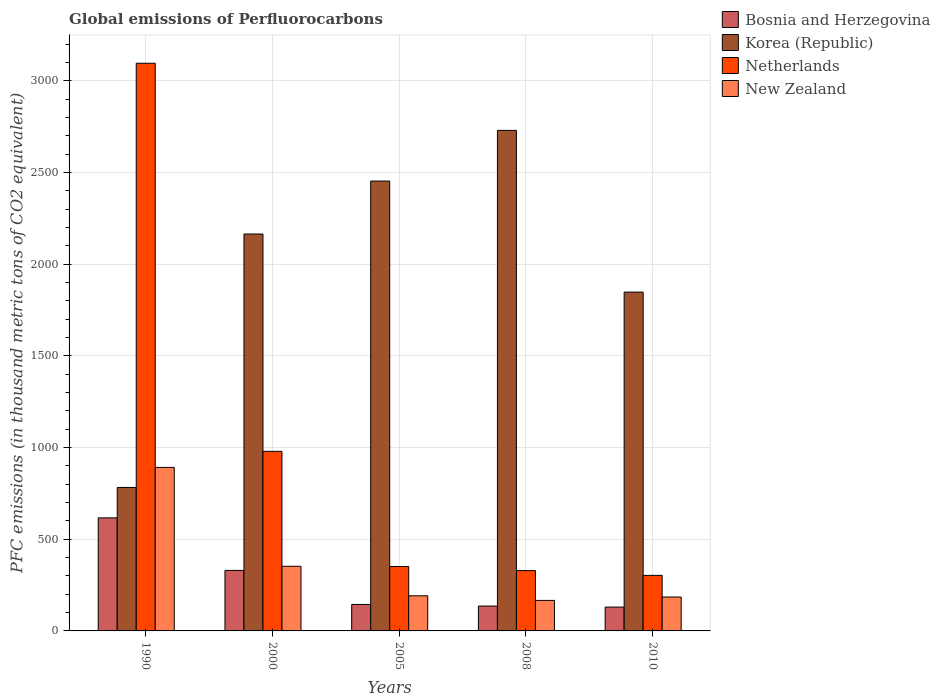How many different coloured bars are there?
Your answer should be very brief. 4. Are the number of bars per tick equal to the number of legend labels?
Provide a succinct answer. Yes. How many bars are there on the 5th tick from the left?
Offer a very short reply. 4. In how many cases, is the number of bars for a given year not equal to the number of legend labels?
Give a very brief answer. 0. What is the global emissions of Perfluorocarbons in Bosnia and Herzegovina in 1990?
Keep it short and to the point. 616.7. Across all years, what is the maximum global emissions of Perfluorocarbons in Korea (Republic)?
Provide a succinct answer. 2730.1. Across all years, what is the minimum global emissions of Perfluorocarbons in Bosnia and Herzegovina?
Provide a short and direct response. 130. What is the total global emissions of Perfluorocarbons in New Zealand in the graph?
Your answer should be very brief. 1787.4. What is the difference between the global emissions of Perfluorocarbons in Korea (Republic) in 1990 and that in 2010?
Your answer should be compact. -1065.4. What is the difference between the global emissions of Perfluorocarbons in Korea (Republic) in 2000 and the global emissions of Perfluorocarbons in Netherlands in 2005?
Your answer should be very brief. 1813.5. What is the average global emissions of Perfluorocarbons in Korea (Republic) per year?
Your answer should be very brief. 1995.86. In the year 2010, what is the difference between the global emissions of Perfluorocarbons in Netherlands and global emissions of Perfluorocarbons in Korea (Republic)?
Offer a very short reply. -1545. In how many years, is the global emissions of Perfluorocarbons in New Zealand greater than 2700 thousand metric tons?
Ensure brevity in your answer.  0. What is the ratio of the global emissions of Perfluorocarbons in Korea (Republic) in 2005 to that in 2008?
Offer a very short reply. 0.9. What is the difference between the highest and the second highest global emissions of Perfluorocarbons in New Zealand?
Your response must be concise. 539.2. What is the difference between the highest and the lowest global emissions of Perfluorocarbons in New Zealand?
Your answer should be compact. 725.4. In how many years, is the global emissions of Perfluorocarbons in Bosnia and Herzegovina greater than the average global emissions of Perfluorocarbons in Bosnia and Herzegovina taken over all years?
Your answer should be compact. 2. Is the sum of the global emissions of Perfluorocarbons in Korea (Republic) in 1990 and 2010 greater than the maximum global emissions of Perfluorocarbons in Netherlands across all years?
Your response must be concise. No. Is it the case that in every year, the sum of the global emissions of Perfluorocarbons in Bosnia and Herzegovina and global emissions of Perfluorocarbons in Korea (Republic) is greater than the sum of global emissions of Perfluorocarbons in New Zealand and global emissions of Perfluorocarbons in Netherlands?
Make the answer very short. No. What does the 4th bar from the left in 2010 represents?
Your answer should be very brief. New Zealand. What does the 4th bar from the right in 2005 represents?
Your response must be concise. Bosnia and Herzegovina. How many bars are there?
Your response must be concise. 20. Are all the bars in the graph horizontal?
Keep it short and to the point. No. How many years are there in the graph?
Your answer should be compact. 5. Does the graph contain any zero values?
Your answer should be compact. No. How many legend labels are there?
Offer a very short reply. 4. What is the title of the graph?
Your answer should be compact. Global emissions of Perfluorocarbons. Does "Liechtenstein" appear as one of the legend labels in the graph?
Keep it short and to the point. No. What is the label or title of the Y-axis?
Make the answer very short. PFC emissions (in thousand metric tons of CO2 equivalent). What is the PFC emissions (in thousand metric tons of CO2 equivalent) of Bosnia and Herzegovina in 1990?
Your answer should be compact. 616.7. What is the PFC emissions (in thousand metric tons of CO2 equivalent) in Korea (Republic) in 1990?
Give a very brief answer. 782.6. What is the PFC emissions (in thousand metric tons of CO2 equivalent) of Netherlands in 1990?
Your answer should be very brief. 3096.2. What is the PFC emissions (in thousand metric tons of CO2 equivalent) in New Zealand in 1990?
Your response must be concise. 891.8. What is the PFC emissions (in thousand metric tons of CO2 equivalent) of Bosnia and Herzegovina in 2000?
Your response must be concise. 329.9. What is the PFC emissions (in thousand metric tons of CO2 equivalent) in Korea (Republic) in 2000?
Keep it short and to the point. 2164.9. What is the PFC emissions (in thousand metric tons of CO2 equivalent) of Netherlands in 2000?
Offer a terse response. 979.5. What is the PFC emissions (in thousand metric tons of CO2 equivalent) in New Zealand in 2000?
Make the answer very short. 352.6. What is the PFC emissions (in thousand metric tons of CO2 equivalent) in Bosnia and Herzegovina in 2005?
Give a very brief answer. 144.4. What is the PFC emissions (in thousand metric tons of CO2 equivalent) in Korea (Republic) in 2005?
Your answer should be very brief. 2453.7. What is the PFC emissions (in thousand metric tons of CO2 equivalent) in Netherlands in 2005?
Provide a succinct answer. 351.4. What is the PFC emissions (in thousand metric tons of CO2 equivalent) in New Zealand in 2005?
Keep it short and to the point. 191.6. What is the PFC emissions (in thousand metric tons of CO2 equivalent) in Bosnia and Herzegovina in 2008?
Give a very brief answer. 135.6. What is the PFC emissions (in thousand metric tons of CO2 equivalent) of Korea (Republic) in 2008?
Your answer should be very brief. 2730.1. What is the PFC emissions (in thousand metric tons of CO2 equivalent) in Netherlands in 2008?
Provide a succinct answer. 329.2. What is the PFC emissions (in thousand metric tons of CO2 equivalent) in New Zealand in 2008?
Offer a terse response. 166.4. What is the PFC emissions (in thousand metric tons of CO2 equivalent) in Bosnia and Herzegovina in 2010?
Make the answer very short. 130. What is the PFC emissions (in thousand metric tons of CO2 equivalent) in Korea (Republic) in 2010?
Provide a succinct answer. 1848. What is the PFC emissions (in thousand metric tons of CO2 equivalent) of Netherlands in 2010?
Provide a succinct answer. 303. What is the PFC emissions (in thousand metric tons of CO2 equivalent) in New Zealand in 2010?
Offer a terse response. 185. Across all years, what is the maximum PFC emissions (in thousand metric tons of CO2 equivalent) in Bosnia and Herzegovina?
Make the answer very short. 616.7. Across all years, what is the maximum PFC emissions (in thousand metric tons of CO2 equivalent) in Korea (Republic)?
Your response must be concise. 2730.1. Across all years, what is the maximum PFC emissions (in thousand metric tons of CO2 equivalent) in Netherlands?
Your answer should be very brief. 3096.2. Across all years, what is the maximum PFC emissions (in thousand metric tons of CO2 equivalent) of New Zealand?
Give a very brief answer. 891.8. Across all years, what is the minimum PFC emissions (in thousand metric tons of CO2 equivalent) in Bosnia and Herzegovina?
Provide a succinct answer. 130. Across all years, what is the minimum PFC emissions (in thousand metric tons of CO2 equivalent) of Korea (Republic)?
Your answer should be compact. 782.6. Across all years, what is the minimum PFC emissions (in thousand metric tons of CO2 equivalent) of Netherlands?
Your response must be concise. 303. Across all years, what is the minimum PFC emissions (in thousand metric tons of CO2 equivalent) in New Zealand?
Offer a very short reply. 166.4. What is the total PFC emissions (in thousand metric tons of CO2 equivalent) of Bosnia and Herzegovina in the graph?
Your answer should be very brief. 1356.6. What is the total PFC emissions (in thousand metric tons of CO2 equivalent) of Korea (Republic) in the graph?
Make the answer very short. 9979.3. What is the total PFC emissions (in thousand metric tons of CO2 equivalent) of Netherlands in the graph?
Your answer should be compact. 5059.3. What is the total PFC emissions (in thousand metric tons of CO2 equivalent) of New Zealand in the graph?
Your answer should be compact. 1787.4. What is the difference between the PFC emissions (in thousand metric tons of CO2 equivalent) of Bosnia and Herzegovina in 1990 and that in 2000?
Provide a short and direct response. 286.8. What is the difference between the PFC emissions (in thousand metric tons of CO2 equivalent) of Korea (Republic) in 1990 and that in 2000?
Provide a short and direct response. -1382.3. What is the difference between the PFC emissions (in thousand metric tons of CO2 equivalent) in Netherlands in 1990 and that in 2000?
Offer a terse response. 2116.7. What is the difference between the PFC emissions (in thousand metric tons of CO2 equivalent) of New Zealand in 1990 and that in 2000?
Keep it short and to the point. 539.2. What is the difference between the PFC emissions (in thousand metric tons of CO2 equivalent) in Bosnia and Herzegovina in 1990 and that in 2005?
Give a very brief answer. 472.3. What is the difference between the PFC emissions (in thousand metric tons of CO2 equivalent) of Korea (Republic) in 1990 and that in 2005?
Provide a succinct answer. -1671.1. What is the difference between the PFC emissions (in thousand metric tons of CO2 equivalent) of Netherlands in 1990 and that in 2005?
Your answer should be very brief. 2744.8. What is the difference between the PFC emissions (in thousand metric tons of CO2 equivalent) of New Zealand in 1990 and that in 2005?
Provide a short and direct response. 700.2. What is the difference between the PFC emissions (in thousand metric tons of CO2 equivalent) in Bosnia and Herzegovina in 1990 and that in 2008?
Give a very brief answer. 481.1. What is the difference between the PFC emissions (in thousand metric tons of CO2 equivalent) of Korea (Republic) in 1990 and that in 2008?
Offer a very short reply. -1947.5. What is the difference between the PFC emissions (in thousand metric tons of CO2 equivalent) of Netherlands in 1990 and that in 2008?
Offer a very short reply. 2767. What is the difference between the PFC emissions (in thousand metric tons of CO2 equivalent) in New Zealand in 1990 and that in 2008?
Give a very brief answer. 725.4. What is the difference between the PFC emissions (in thousand metric tons of CO2 equivalent) in Bosnia and Herzegovina in 1990 and that in 2010?
Make the answer very short. 486.7. What is the difference between the PFC emissions (in thousand metric tons of CO2 equivalent) in Korea (Republic) in 1990 and that in 2010?
Provide a succinct answer. -1065.4. What is the difference between the PFC emissions (in thousand metric tons of CO2 equivalent) of Netherlands in 1990 and that in 2010?
Provide a succinct answer. 2793.2. What is the difference between the PFC emissions (in thousand metric tons of CO2 equivalent) in New Zealand in 1990 and that in 2010?
Keep it short and to the point. 706.8. What is the difference between the PFC emissions (in thousand metric tons of CO2 equivalent) in Bosnia and Herzegovina in 2000 and that in 2005?
Make the answer very short. 185.5. What is the difference between the PFC emissions (in thousand metric tons of CO2 equivalent) in Korea (Republic) in 2000 and that in 2005?
Provide a succinct answer. -288.8. What is the difference between the PFC emissions (in thousand metric tons of CO2 equivalent) of Netherlands in 2000 and that in 2005?
Make the answer very short. 628.1. What is the difference between the PFC emissions (in thousand metric tons of CO2 equivalent) of New Zealand in 2000 and that in 2005?
Your answer should be compact. 161. What is the difference between the PFC emissions (in thousand metric tons of CO2 equivalent) in Bosnia and Herzegovina in 2000 and that in 2008?
Ensure brevity in your answer.  194.3. What is the difference between the PFC emissions (in thousand metric tons of CO2 equivalent) in Korea (Republic) in 2000 and that in 2008?
Provide a succinct answer. -565.2. What is the difference between the PFC emissions (in thousand metric tons of CO2 equivalent) of Netherlands in 2000 and that in 2008?
Keep it short and to the point. 650.3. What is the difference between the PFC emissions (in thousand metric tons of CO2 equivalent) in New Zealand in 2000 and that in 2008?
Your answer should be very brief. 186.2. What is the difference between the PFC emissions (in thousand metric tons of CO2 equivalent) in Bosnia and Herzegovina in 2000 and that in 2010?
Your answer should be compact. 199.9. What is the difference between the PFC emissions (in thousand metric tons of CO2 equivalent) in Korea (Republic) in 2000 and that in 2010?
Keep it short and to the point. 316.9. What is the difference between the PFC emissions (in thousand metric tons of CO2 equivalent) of Netherlands in 2000 and that in 2010?
Provide a short and direct response. 676.5. What is the difference between the PFC emissions (in thousand metric tons of CO2 equivalent) in New Zealand in 2000 and that in 2010?
Provide a short and direct response. 167.6. What is the difference between the PFC emissions (in thousand metric tons of CO2 equivalent) of Bosnia and Herzegovina in 2005 and that in 2008?
Offer a very short reply. 8.8. What is the difference between the PFC emissions (in thousand metric tons of CO2 equivalent) of Korea (Republic) in 2005 and that in 2008?
Provide a succinct answer. -276.4. What is the difference between the PFC emissions (in thousand metric tons of CO2 equivalent) of New Zealand in 2005 and that in 2008?
Offer a terse response. 25.2. What is the difference between the PFC emissions (in thousand metric tons of CO2 equivalent) of Bosnia and Herzegovina in 2005 and that in 2010?
Offer a terse response. 14.4. What is the difference between the PFC emissions (in thousand metric tons of CO2 equivalent) in Korea (Republic) in 2005 and that in 2010?
Your answer should be compact. 605.7. What is the difference between the PFC emissions (in thousand metric tons of CO2 equivalent) of Netherlands in 2005 and that in 2010?
Keep it short and to the point. 48.4. What is the difference between the PFC emissions (in thousand metric tons of CO2 equivalent) of New Zealand in 2005 and that in 2010?
Your response must be concise. 6.6. What is the difference between the PFC emissions (in thousand metric tons of CO2 equivalent) in Korea (Republic) in 2008 and that in 2010?
Provide a succinct answer. 882.1. What is the difference between the PFC emissions (in thousand metric tons of CO2 equivalent) in Netherlands in 2008 and that in 2010?
Your response must be concise. 26.2. What is the difference between the PFC emissions (in thousand metric tons of CO2 equivalent) of New Zealand in 2008 and that in 2010?
Your answer should be very brief. -18.6. What is the difference between the PFC emissions (in thousand metric tons of CO2 equivalent) in Bosnia and Herzegovina in 1990 and the PFC emissions (in thousand metric tons of CO2 equivalent) in Korea (Republic) in 2000?
Give a very brief answer. -1548.2. What is the difference between the PFC emissions (in thousand metric tons of CO2 equivalent) of Bosnia and Herzegovina in 1990 and the PFC emissions (in thousand metric tons of CO2 equivalent) of Netherlands in 2000?
Make the answer very short. -362.8. What is the difference between the PFC emissions (in thousand metric tons of CO2 equivalent) in Bosnia and Herzegovina in 1990 and the PFC emissions (in thousand metric tons of CO2 equivalent) in New Zealand in 2000?
Your answer should be very brief. 264.1. What is the difference between the PFC emissions (in thousand metric tons of CO2 equivalent) of Korea (Republic) in 1990 and the PFC emissions (in thousand metric tons of CO2 equivalent) of Netherlands in 2000?
Keep it short and to the point. -196.9. What is the difference between the PFC emissions (in thousand metric tons of CO2 equivalent) of Korea (Republic) in 1990 and the PFC emissions (in thousand metric tons of CO2 equivalent) of New Zealand in 2000?
Your answer should be compact. 430. What is the difference between the PFC emissions (in thousand metric tons of CO2 equivalent) of Netherlands in 1990 and the PFC emissions (in thousand metric tons of CO2 equivalent) of New Zealand in 2000?
Your answer should be compact. 2743.6. What is the difference between the PFC emissions (in thousand metric tons of CO2 equivalent) of Bosnia and Herzegovina in 1990 and the PFC emissions (in thousand metric tons of CO2 equivalent) of Korea (Republic) in 2005?
Offer a very short reply. -1837. What is the difference between the PFC emissions (in thousand metric tons of CO2 equivalent) in Bosnia and Herzegovina in 1990 and the PFC emissions (in thousand metric tons of CO2 equivalent) in Netherlands in 2005?
Offer a terse response. 265.3. What is the difference between the PFC emissions (in thousand metric tons of CO2 equivalent) in Bosnia and Herzegovina in 1990 and the PFC emissions (in thousand metric tons of CO2 equivalent) in New Zealand in 2005?
Provide a short and direct response. 425.1. What is the difference between the PFC emissions (in thousand metric tons of CO2 equivalent) in Korea (Republic) in 1990 and the PFC emissions (in thousand metric tons of CO2 equivalent) in Netherlands in 2005?
Provide a succinct answer. 431.2. What is the difference between the PFC emissions (in thousand metric tons of CO2 equivalent) in Korea (Republic) in 1990 and the PFC emissions (in thousand metric tons of CO2 equivalent) in New Zealand in 2005?
Offer a very short reply. 591. What is the difference between the PFC emissions (in thousand metric tons of CO2 equivalent) of Netherlands in 1990 and the PFC emissions (in thousand metric tons of CO2 equivalent) of New Zealand in 2005?
Your response must be concise. 2904.6. What is the difference between the PFC emissions (in thousand metric tons of CO2 equivalent) in Bosnia and Herzegovina in 1990 and the PFC emissions (in thousand metric tons of CO2 equivalent) in Korea (Republic) in 2008?
Ensure brevity in your answer.  -2113.4. What is the difference between the PFC emissions (in thousand metric tons of CO2 equivalent) of Bosnia and Herzegovina in 1990 and the PFC emissions (in thousand metric tons of CO2 equivalent) of Netherlands in 2008?
Your answer should be very brief. 287.5. What is the difference between the PFC emissions (in thousand metric tons of CO2 equivalent) of Bosnia and Herzegovina in 1990 and the PFC emissions (in thousand metric tons of CO2 equivalent) of New Zealand in 2008?
Offer a very short reply. 450.3. What is the difference between the PFC emissions (in thousand metric tons of CO2 equivalent) in Korea (Republic) in 1990 and the PFC emissions (in thousand metric tons of CO2 equivalent) in Netherlands in 2008?
Provide a succinct answer. 453.4. What is the difference between the PFC emissions (in thousand metric tons of CO2 equivalent) in Korea (Republic) in 1990 and the PFC emissions (in thousand metric tons of CO2 equivalent) in New Zealand in 2008?
Your answer should be very brief. 616.2. What is the difference between the PFC emissions (in thousand metric tons of CO2 equivalent) of Netherlands in 1990 and the PFC emissions (in thousand metric tons of CO2 equivalent) of New Zealand in 2008?
Make the answer very short. 2929.8. What is the difference between the PFC emissions (in thousand metric tons of CO2 equivalent) in Bosnia and Herzegovina in 1990 and the PFC emissions (in thousand metric tons of CO2 equivalent) in Korea (Republic) in 2010?
Your answer should be very brief. -1231.3. What is the difference between the PFC emissions (in thousand metric tons of CO2 equivalent) of Bosnia and Herzegovina in 1990 and the PFC emissions (in thousand metric tons of CO2 equivalent) of Netherlands in 2010?
Make the answer very short. 313.7. What is the difference between the PFC emissions (in thousand metric tons of CO2 equivalent) in Bosnia and Herzegovina in 1990 and the PFC emissions (in thousand metric tons of CO2 equivalent) in New Zealand in 2010?
Make the answer very short. 431.7. What is the difference between the PFC emissions (in thousand metric tons of CO2 equivalent) of Korea (Republic) in 1990 and the PFC emissions (in thousand metric tons of CO2 equivalent) of Netherlands in 2010?
Provide a succinct answer. 479.6. What is the difference between the PFC emissions (in thousand metric tons of CO2 equivalent) of Korea (Republic) in 1990 and the PFC emissions (in thousand metric tons of CO2 equivalent) of New Zealand in 2010?
Provide a succinct answer. 597.6. What is the difference between the PFC emissions (in thousand metric tons of CO2 equivalent) in Netherlands in 1990 and the PFC emissions (in thousand metric tons of CO2 equivalent) in New Zealand in 2010?
Offer a very short reply. 2911.2. What is the difference between the PFC emissions (in thousand metric tons of CO2 equivalent) of Bosnia and Herzegovina in 2000 and the PFC emissions (in thousand metric tons of CO2 equivalent) of Korea (Republic) in 2005?
Keep it short and to the point. -2123.8. What is the difference between the PFC emissions (in thousand metric tons of CO2 equivalent) of Bosnia and Herzegovina in 2000 and the PFC emissions (in thousand metric tons of CO2 equivalent) of Netherlands in 2005?
Your answer should be very brief. -21.5. What is the difference between the PFC emissions (in thousand metric tons of CO2 equivalent) in Bosnia and Herzegovina in 2000 and the PFC emissions (in thousand metric tons of CO2 equivalent) in New Zealand in 2005?
Offer a terse response. 138.3. What is the difference between the PFC emissions (in thousand metric tons of CO2 equivalent) in Korea (Republic) in 2000 and the PFC emissions (in thousand metric tons of CO2 equivalent) in Netherlands in 2005?
Offer a terse response. 1813.5. What is the difference between the PFC emissions (in thousand metric tons of CO2 equivalent) in Korea (Republic) in 2000 and the PFC emissions (in thousand metric tons of CO2 equivalent) in New Zealand in 2005?
Keep it short and to the point. 1973.3. What is the difference between the PFC emissions (in thousand metric tons of CO2 equivalent) in Netherlands in 2000 and the PFC emissions (in thousand metric tons of CO2 equivalent) in New Zealand in 2005?
Offer a terse response. 787.9. What is the difference between the PFC emissions (in thousand metric tons of CO2 equivalent) in Bosnia and Herzegovina in 2000 and the PFC emissions (in thousand metric tons of CO2 equivalent) in Korea (Republic) in 2008?
Make the answer very short. -2400.2. What is the difference between the PFC emissions (in thousand metric tons of CO2 equivalent) in Bosnia and Herzegovina in 2000 and the PFC emissions (in thousand metric tons of CO2 equivalent) in Netherlands in 2008?
Provide a short and direct response. 0.7. What is the difference between the PFC emissions (in thousand metric tons of CO2 equivalent) of Bosnia and Herzegovina in 2000 and the PFC emissions (in thousand metric tons of CO2 equivalent) of New Zealand in 2008?
Give a very brief answer. 163.5. What is the difference between the PFC emissions (in thousand metric tons of CO2 equivalent) in Korea (Republic) in 2000 and the PFC emissions (in thousand metric tons of CO2 equivalent) in Netherlands in 2008?
Keep it short and to the point. 1835.7. What is the difference between the PFC emissions (in thousand metric tons of CO2 equivalent) of Korea (Republic) in 2000 and the PFC emissions (in thousand metric tons of CO2 equivalent) of New Zealand in 2008?
Provide a succinct answer. 1998.5. What is the difference between the PFC emissions (in thousand metric tons of CO2 equivalent) of Netherlands in 2000 and the PFC emissions (in thousand metric tons of CO2 equivalent) of New Zealand in 2008?
Make the answer very short. 813.1. What is the difference between the PFC emissions (in thousand metric tons of CO2 equivalent) in Bosnia and Herzegovina in 2000 and the PFC emissions (in thousand metric tons of CO2 equivalent) in Korea (Republic) in 2010?
Make the answer very short. -1518.1. What is the difference between the PFC emissions (in thousand metric tons of CO2 equivalent) of Bosnia and Herzegovina in 2000 and the PFC emissions (in thousand metric tons of CO2 equivalent) of Netherlands in 2010?
Offer a terse response. 26.9. What is the difference between the PFC emissions (in thousand metric tons of CO2 equivalent) in Bosnia and Herzegovina in 2000 and the PFC emissions (in thousand metric tons of CO2 equivalent) in New Zealand in 2010?
Ensure brevity in your answer.  144.9. What is the difference between the PFC emissions (in thousand metric tons of CO2 equivalent) of Korea (Republic) in 2000 and the PFC emissions (in thousand metric tons of CO2 equivalent) of Netherlands in 2010?
Your answer should be very brief. 1861.9. What is the difference between the PFC emissions (in thousand metric tons of CO2 equivalent) in Korea (Republic) in 2000 and the PFC emissions (in thousand metric tons of CO2 equivalent) in New Zealand in 2010?
Provide a succinct answer. 1979.9. What is the difference between the PFC emissions (in thousand metric tons of CO2 equivalent) of Netherlands in 2000 and the PFC emissions (in thousand metric tons of CO2 equivalent) of New Zealand in 2010?
Ensure brevity in your answer.  794.5. What is the difference between the PFC emissions (in thousand metric tons of CO2 equivalent) in Bosnia and Herzegovina in 2005 and the PFC emissions (in thousand metric tons of CO2 equivalent) in Korea (Republic) in 2008?
Make the answer very short. -2585.7. What is the difference between the PFC emissions (in thousand metric tons of CO2 equivalent) in Bosnia and Herzegovina in 2005 and the PFC emissions (in thousand metric tons of CO2 equivalent) in Netherlands in 2008?
Ensure brevity in your answer.  -184.8. What is the difference between the PFC emissions (in thousand metric tons of CO2 equivalent) in Korea (Republic) in 2005 and the PFC emissions (in thousand metric tons of CO2 equivalent) in Netherlands in 2008?
Provide a succinct answer. 2124.5. What is the difference between the PFC emissions (in thousand metric tons of CO2 equivalent) of Korea (Republic) in 2005 and the PFC emissions (in thousand metric tons of CO2 equivalent) of New Zealand in 2008?
Ensure brevity in your answer.  2287.3. What is the difference between the PFC emissions (in thousand metric tons of CO2 equivalent) of Netherlands in 2005 and the PFC emissions (in thousand metric tons of CO2 equivalent) of New Zealand in 2008?
Make the answer very short. 185. What is the difference between the PFC emissions (in thousand metric tons of CO2 equivalent) of Bosnia and Herzegovina in 2005 and the PFC emissions (in thousand metric tons of CO2 equivalent) of Korea (Republic) in 2010?
Make the answer very short. -1703.6. What is the difference between the PFC emissions (in thousand metric tons of CO2 equivalent) of Bosnia and Herzegovina in 2005 and the PFC emissions (in thousand metric tons of CO2 equivalent) of Netherlands in 2010?
Give a very brief answer. -158.6. What is the difference between the PFC emissions (in thousand metric tons of CO2 equivalent) of Bosnia and Herzegovina in 2005 and the PFC emissions (in thousand metric tons of CO2 equivalent) of New Zealand in 2010?
Ensure brevity in your answer.  -40.6. What is the difference between the PFC emissions (in thousand metric tons of CO2 equivalent) in Korea (Republic) in 2005 and the PFC emissions (in thousand metric tons of CO2 equivalent) in Netherlands in 2010?
Provide a succinct answer. 2150.7. What is the difference between the PFC emissions (in thousand metric tons of CO2 equivalent) of Korea (Republic) in 2005 and the PFC emissions (in thousand metric tons of CO2 equivalent) of New Zealand in 2010?
Your response must be concise. 2268.7. What is the difference between the PFC emissions (in thousand metric tons of CO2 equivalent) of Netherlands in 2005 and the PFC emissions (in thousand metric tons of CO2 equivalent) of New Zealand in 2010?
Give a very brief answer. 166.4. What is the difference between the PFC emissions (in thousand metric tons of CO2 equivalent) of Bosnia and Herzegovina in 2008 and the PFC emissions (in thousand metric tons of CO2 equivalent) of Korea (Republic) in 2010?
Your answer should be very brief. -1712.4. What is the difference between the PFC emissions (in thousand metric tons of CO2 equivalent) of Bosnia and Herzegovina in 2008 and the PFC emissions (in thousand metric tons of CO2 equivalent) of Netherlands in 2010?
Your response must be concise. -167.4. What is the difference between the PFC emissions (in thousand metric tons of CO2 equivalent) in Bosnia and Herzegovina in 2008 and the PFC emissions (in thousand metric tons of CO2 equivalent) in New Zealand in 2010?
Offer a terse response. -49.4. What is the difference between the PFC emissions (in thousand metric tons of CO2 equivalent) in Korea (Republic) in 2008 and the PFC emissions (in thousand metric tons of CO2 equivalent) in Netherlands in 2010?
Your answer should be compact. 2427.1. What is the difference between the PFC emissions (in thousand metric tons of CO2 equivalent) of Korea (Republic) in 2008 and the PFC emissions (in thousand metric tons of CO2 equivalent) of New Zealand in 2010?
Provide a short and direct response. 2545.1. What is the difference between the PFC emissions (in thousand metric tons of CO2 equivalent) of Netherlands in 2008 and the PFC emissions (in thousand metric tons of CO2 equivalent) of New Zealand in 2010?
Your answer should be compact. 144.2. What is the average PFC emissions (in thousand metric tons of CO2 equivalent) of Bosnia and Herzegovina per year?
Your answer should be very brief. 271.32. What is the average PFC emissions (in thousand metric tons of CO2 equivalent) of Korea (Republic) per year?
Offer a very short reply. 1995.86. What is the average PFC emissions (in thousand metric tons of CO2 equivalent) in Netherlands per year?
Your response must be concise. 1011.86. What is the average PFC emissions (in thousand metric tons of CO2 equivalent) in New Zealand per year?
Keep it short and to the point. 357.48. In the year 1990, what is the difference between the PFC emissions (in thousand metric tons of CO2 equivalent) in Bosnia and Herzegovina and PFC emissions (in thousand metric tons of CO2 equivalent) in Korea (Republic)?
Offer a very short reply. -165.9. In the year 1990, what is the difference between the PFC emissions (in thousand metric tons of CO2 equivalent) of Bosnia and Herzegovina and PFC emissions (in thousand metric tons of CO2 equivalent) of Netherlands?
Keep it short and to the point. -2479.5. In the year 1990, what is the difference between the PFC emissions (in thousand metric tons of CO2 equivalent) in Bosnia and Herzegovina and PFC emissions (in thousand metric tons of CO2 equivalent) in New Zealand?
Your answer should be compact. -275.1. In the year 1990, what is the difference between the PFC emissions (in thousand metric tons of CO2 equivalent) of Korea (Republic) and PFC emissions (in thousand metric tons of CO2 equivalent) of Netherlands?
Offer a very short reply. -2313.6. In the year 1990, what is the difference between the PFC emissions (in thousand metric tons of CO2 equivalent) of Korea (Republic) and PFC emissions (in thousand metric tons of CO2 equivalent) of New Zealand?
Your answer should be very brief. -109.2. In the year 1990, what is the difference between the PFC emissions (in thousand metric tons of CO2 equivalent) of Netherlands and PFC emissions (in thousand metric tons of CO2 equivalent) of New Zealand?
Your answer should be compact. 2204.4. In the year 2000, what is the difference between the PFC emissions (in thousand metric tons of CO2 equivalent) in Bosnia and Herzegovina and PFC emissions (in thousand metric tons of CO2 equivalent) in Korea (Republic)?
Give a very brief answer. -1835. In the year 2000, what is the difference between the PFC emissions (in thousand metric tons of CO2 equivalent) in Bosnia and Herzegovina and PFC emissions (in thousand metric tons of CO2 equivalent) in Netherlands?
Your answer should be compact. -649.6. In the year 2000, what is the difference between the PFC emissions (in thousand metric tons of CO2 equivalent) in Bosnia and Herzegovina and PFC emissions (in thousand metric tons of CO2 equivalent) in New Zealand?
Your response must be concise. -22.7. In the year 2000, what is the difference between the PFC emissions (in thousand metric tons of CO2 equivalent) of Korea (Republic) and PFC emissions (in thousand metric tons of CO2 equivalent) of Netherlands?
Give a very brief answer. 1185.4. In the year 2000, what is the difference between the PFC emissions (in thousand metric tons of CO2 equivalent) of Korea (Republic) and PFC emissions (in thousand metric tons of CO2 equivalent) of New Zealand?
Offer a very short reply. 1812.3. In the year 2000, what is the difference between the PFC emissions (in thousand metric tons of CO2 equivalent) in Netherlands and PFC emissions (in thousand metric tons of CO2 equivalent) in New Zealand?
Provide a succinct answer. 626.9. In the year 2005, what is the difference between the PFC emissions (in thousand metric tons of CO2 equivalent) of Bosnia and Herzegovina and PFC emissions (in thousand metric tons of CO2 equivalent) of Korea (Republic)?
Your answer should be compact. -2309.3. In the year 2005, what is the difference between the PFC emissions (in thousand metric tons of CO2 equivalent) of Bosnia and Herzegovina and PFC emissions (in thousand metric tons of CO2 equivalent) of Netherlands?
Make the answer very short. -207. In the year 2005, what is the difference between the PFC emissions (in thousand metric tons of CO2 equivalent) in Bosnia and Herzegovina and PFC emissions (in thousand metric tons of CO2 equivalent) in New Zealand?
Provide a short and direct response. -47.2. In the year 2005, what is the difference between the PFC emissions (in thousand metric tons of CO2 equivalent) of Korea (Republic) and PFC emissions (in thousand metric tons of CO2 equivalent) of Netherlands?
Offer a very short reply. 2102.3. In the year 2005, what is the difference between the PFC emissions (in thousand metric tons of CO2 equivalent) in Korea (Republic) and PFC emissions (in thousand metric tons of CO2 equivalent) in New Zealand?
Provide a succinct answer. 2262.1. In the year 2005, what is the difference between the PFC emissions (in thousand metric tons of CO2 equivalent) in Netherlands and PFC emissions (in thousand metric tons of CO2 equivalent) in New Zealand?
Your answer should be compact. 159.8. In the year 2008, what is the difference between the PFC emissions (in thousand metric tons of CO2 equivalent) of Bosnia and Herzegovina and PFC emissions (in thousand metric tons of CO2 equivalent) of Korea (Republic)?
Ensure brevity in your answer.  -2594.5. In the year 2008, what is the difference between the PFC emissions (in thousand metric tons of CO2 equivalent) in Bosnia and Herzegovina and PFC emissions (in thousand metric tons of CO2 equivalent) in Netherlands?
Provide a short and direct response. -193.6. In the year 2008, what is the difference between the PFC emissions (in thousand metric tons of CO2 equivalent) of Bosnia and Herzegovina and PFC emissions (in thousand metric tons of CO2 equivalent) of New Zealand?
Ensure brevity in your answer.  -30.8. In the year 2008, what is the difference between the PFC emissions (in thousand metric tons of CO2 equivalent) in Korea (Republic) and PFC emissions (in thousand metric tons of CO2 equivalent) in Netherlands?
Offer a terse response. 2400.9. In the year 2008, what is the difference between the PFC emissions (in thousand metric tons of CO2 equivalent) in Korea (Republic) and PFC emissions (in thousand metric tons of CO2 equivalent) in New Zealand?
Ensure brevity in your answer.  2563.7. In the year 2008, what is the difference between the PFC emissions (in thousand metric tons of CO2 equivalent) in Netherlands and PFC emissions (in thousand metric tons of CO2 equivalent) in New Zealand?
Offer a terse response. 162.8. In the year 2010, what is the difference between the PFC emissions (in thousand metric tons of CO2 equivalent) of Bosnia and Herzegovina and PFC emissions (in thousand metric tons of CO2 equivalent) of Korea (Republic)?
Your answer should be compact. -1718. In the year 2010, what is the difference between the PFC emissions (in thousand metric tons of CO2 equivalent) in Bosnia and Herzegovina and PFC emissions (in thousand metric tons of CO2 equivalent) in Netherlands?
Offer a very short reply. -173. In the year 2010, what is the difference between the PFC emissions (in thousand metric tons of CO2 equivalent) of Bosnia and Herzegovina and PFC emissions (in thousand metric tons of CO2 equivalent) of New Zealand?
Give a very brief answer. -55. In the year 2010, what is the difference between the PFC emissions (in thousand metric tons of CO2 equivalent) in Korea (Republic) and PFC emissions (in thousand metric tons of CO2 equivalent) in Netherlands?
Keep it short and to the point. 1545. In the year 2010, what is the difference between the PFC emissions (in thousand metric tons of CO2 equivalent) in Korea (Republic) and PFC emissions (in thousand metric tons of CO2 equivalent) in New Zealand?
Your answer should be very brief. 1663. In the year 2010, what is the difference between the PFC emissions (in thousand metric tons of CO2 equivalent) in Netherlands and PFC emissions (in thousand metric tons of CO2 equivalent) in New Zealand?
Ensure brevity in your answer.  118. What is the ratio of the PFC emissions (in thousand metric tons of CO2 equivalent) of Bosnia and Herzegovina in 1990 to that in 2000?
Offer a very short reply. 1.87. What is the ratio of the PFC emissions (in thousand metric tons of CO2 equivalent) of Korea (Republic) in 1990 to that in 2000?
Provide a succinct answer. 0.36. What is the ratio of the PFC emissions (in thousand metric tons of CO2 equivalent) of Netherlands in 1990 to that in 2000?
Offer a terse response. 3.16. What is the ratio of the PFC emissions (in thousand metric tons of CO2 equivalent) of New Zealand in 1990 to that in 2000?
Keep it short and to the point. 2.53. What is the ratio of the PFC emissions (in thousand metric tons of CO2 equivalent) in Bosnia and Herzegovina in 1990 to that in 2005?
Your answer should be very brief. 4.27. What is the ratio of the PFC emissions (in thousand metric tons of CO2 equivalent) in Korea (Republic) in 1990 to that in 2005?
Provide a succinct answer. 0.32. What is the ratio of the PFC emissions (in thousand metric tons of CO2 equivalent) of Netherlands in 1990 to that in 2005?
Make the answer very short. 8.81. What is the ratio of the PFC emissions (in thousand metric tons of CO2 equivalent) in New Zealand in 1990 to that in 2005?
Your answer should be very brief. 4.65. What is the ratio of the PFC emissions (in thousand metric tons of CO2 equivalent) of Bosnia and Herzegovina in 1990 to that in 2008?
Give a very brief answer. 4.55. What is the ratio of the PFC emissions (in thousand metric tons of CO2 equivalent) in Korea (Republic) in 1990 to that in 2008?
Offer a very short reply. 0.29. What is the ratio of the PFC emissions (in thousand metric tons of CO2 equivalent) of Netherlands in 1990 to that in 2008?
Offer a very short reply. 9.41. What is the ratio of the PFC emissions (in thousand metric tons of CO2 equivalent) of New Zealand in 1990 to that in 2008?
Provide a succinct answer. 5.36. What is the ratio of the PFC emissions (in thousand metric tons of CO2 equivalent) in Bosnia and Herzegovina in 1990 to that in 2010?
Your answer should be very brief. 4.74. What is the ratio of the PFC emissions (in thousand metric tons of CO2 equivalent) of Korea (Republic) in 1990 to that in 2010?
Make the answer very short. 0.42. What is the ratio of the PFC emissions (in thousand metric tons of CO2 equivalent) of Netherlands in 1990 to that in 2010?
Ensure brevity in your answer.  10.22. What is the ratio of the PFC emissions (in thousand metric tons of CO2 equivalent) in New Zealand in 1990 to that in 2010?
Give a very brief answer. 4.82. What is the ratio of the PFC emissions (in thousand metric tons of CO2 equivalent) in Bosnia and Herzegovina in 2000 to that in 2005?
Keep it short and to the point. 2.28. What is the ratio of the PFC emissions (in thousand metric tons of CO2 equivalent) in Korea (Republic) in 2000 to that in 2005?
Provide a succinct answer. 0.88. What is the ratio of the PFC emissions (in thousand metric tons of CO2 equivalent) of Netherlands in 2000 to that in 2005?
Your response must be concise. 2.79. What is the ratio of the PFC emissions (in thousand metric tons of CO2 equivalent) of New Zealand in 2000 to that in 2005?
Ensure brevity in your answer.  1.84. What is the ratio of the PFC emissions (in thousand metric tons of CO2 equivalent) in Bosnia and Herzegovina in 2000 to that in 2008?
Your answer should be very brief. 2.43. What is the ratio of the PFC emissions (in thousand metric tons of CO2 equivalent) in Korea (Republic) in 2000 to that in 2008?
Keep it short and to the point. 0.79. What is the ratio of the PFC emissions (in thousand metric tons of CO2 equivalent) of Netherlands in 2000 to that in 2008?
Your answer should be compact. 2.98. What is the ratio of the PFC emissions (in thousand metric tons of CO2 equivalent) in New Zealand in 2000 to that in 2008?
Your answer should be very brief. 2.12. What is the ratio of the PFC emissions (in thousand metric tons of CO2 equivalent) of Bosnia and Herzegovina in 2000 to that in 2010?
Your response must be concise. 2.54. What is the ratio of the PFC emissions (in thousand metric tons of CO2 equivalent) in Korea (Republic) in 2000 to that in 2010?
Your response must be concise. 1.17. What is the ratio of the PFC emissions (in thousand metric tons of CO2 equivalent) of Netherlands in 2000 to that in 2010?
Provide a short and direct response. 3.23. What is the ratio of the PFC emissions (in thousand metric tons of CO2 equivalent) in New Zealand in 2000 to that in 2010?
Offer a very short reply. 1.91. What is the ratio of the PFC emissions (in thousand metric tons of CO2 equivalent) in Bosnia and Herzegovina in 2005 to that in 2008?
Ensure brevity in your answer.  1.06. What is the ratio of the PFC emissions (in thousand metric tons of CO2 equivalent) of Korea (Republic) in 2005 to that in 2008?
Offer a very short reply. 0.9. What is the ratio of the PFC emissions (in thousand metric tons of CO2 equivalent) in Netherlands in 2005 to that in 2008?
Make the answer very short. 1.07. What is the ratio of the PFC emissions (in thousand metric tons of CO2 equivalent) of New Zealand in 2005 to that in 2008?
Provide a short and direct response. 1.15. What is the ratio of the PFC emissions (in thousand metric tons of CO2 equivalent) in Bosnia and Herzegovina in 2005 to that in 2010?
Offer a terse response. 1.11. What is the ratio of the PFC emissions (in thousand metric tons of CO2 equivalent) in Korea (Republic) in 2005 to that in 2010?
Your answer should be very brief. 1.33. What is the ratio of the PFC emissions (in thousand metric tons of CO2 equivalent) in Netherlands in 2005 to that in 2010?
Your answer should be very brief. 1.16. What is the ratio of the PFC emissions (in thousand metric tons of CO2 equivalent) in New Zealand in 2005 to that in 2010?
Provide a short and direct response. 1.04. What is the ratio of the PFC emissions (in thousand metric tons of CO2 equivalent) of Bosnia and Herzegovina in 2008 to that in 2010?
Your response must be concise. 1.04. What is the ratio of the PFC emissions (in thousand metric tons of CO2 equivalent) of Korea (Republic) in 2008 to that in 2010?
Offer a terse response. 1.48. What is the ratio of the PFC emissions (in thousand metric tons of CO2 equivalent) of Netherlands in 2008 to that in 2010?
Your answer should be very brief. 1.09. What is the ratio of the PFC emissions (in thousand metric tons of CO2 equivalent) in New Zealand in 2008 to that in 2010?
Offer a terse response. 0.9. What is the difference between the highest and the second highest PFC emissions (in thousand metric tons of CO2 equivalent) in Bosnia and Herzegovina?
Provide a succinct answer. 286.8. What is the difference between the highest and the second highest PFC emissions (in thousand metric tons of CO2 equivalent) of Korea (Republic)?
Your answer should be compact. 276.4. What is the difference between the highest and the second highest PFC emissions (in thousand metric tons of CO2 equivalent) in Netherlands?
Provide a succinct answer. 2116.7. What is the difference between the highest and the second highest PFC emissions (in thousand metric tons of CO2 equivalent) in New Zealand?
Keep it short and to the point. 539.2. What is the difference between the highest and the lowest PFC emissions (in thousand metric tons of CO2 equivalent) of Bosnia and Herzegovina?
Provide a short and direct response. 486.7. What is the difference between the highest and the lowest PFC emissions (in thousand metric tons of CO2 equivalent) of Korea (Republic)?
Your answer should be very brief. 1947.5. What is the difference between the highest and the lowest PFC emissions (in thousand metric tons of CO2 equivalent) in Netherlands?
Keep it short and to the point. 2793.2. What is the difference between the highest and the lowest PFC emissions (in thousand metric tons of CO2 equivalent) in New Zealand?
Provide a short and direct response. 725.4. 